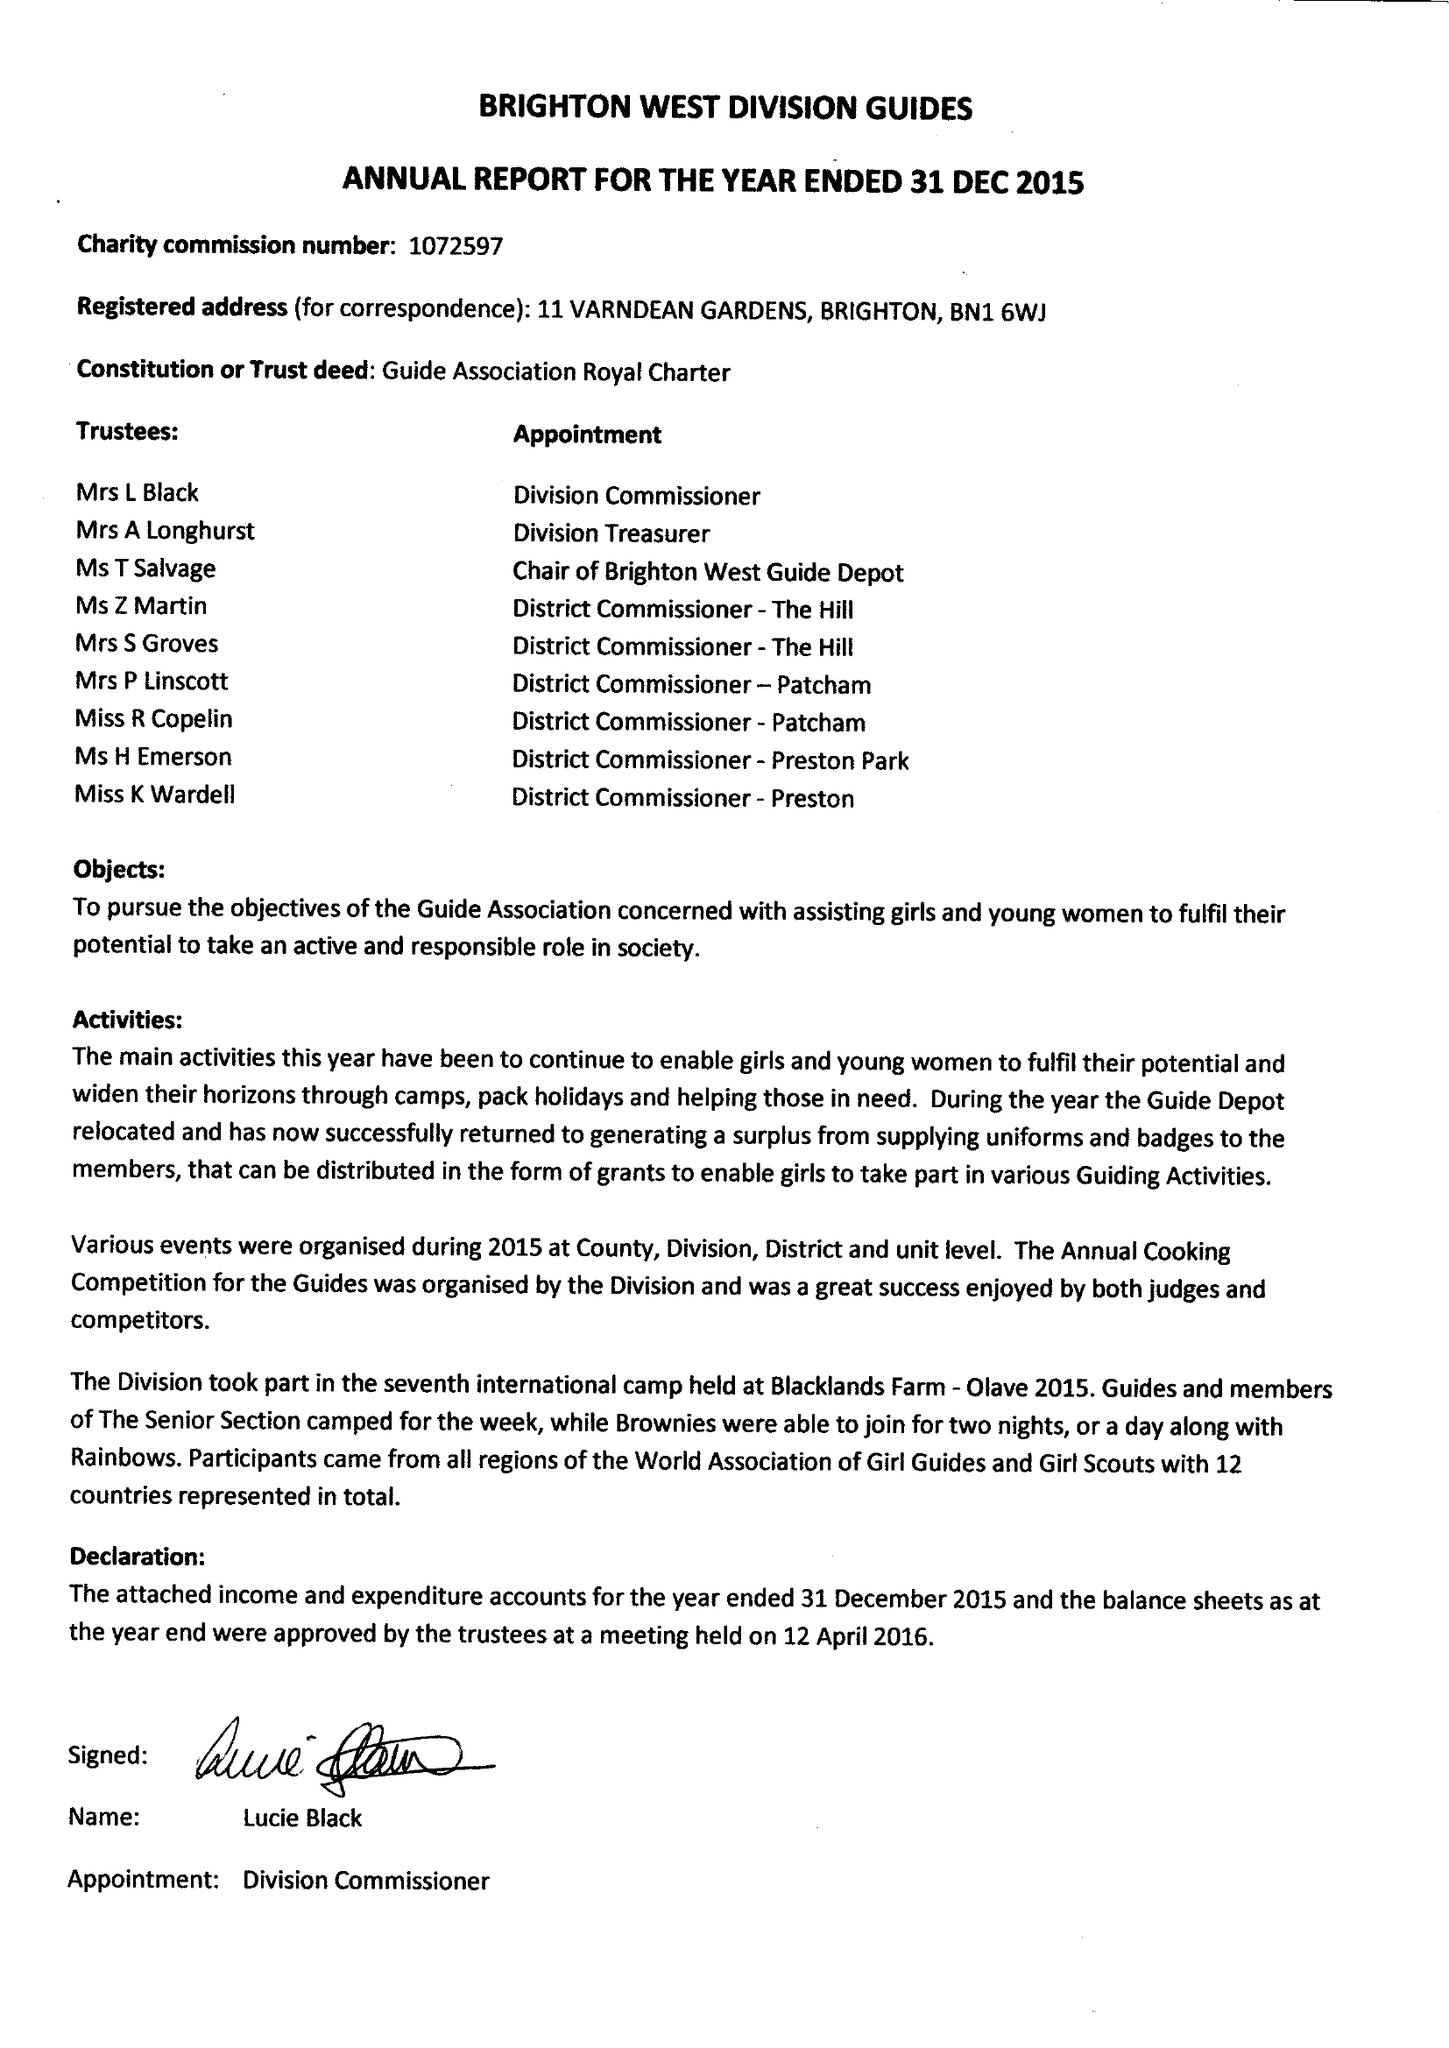What is the value for the income_annually_in_british_pounds?
Answer the question using a single word or phrase. 25423.00 